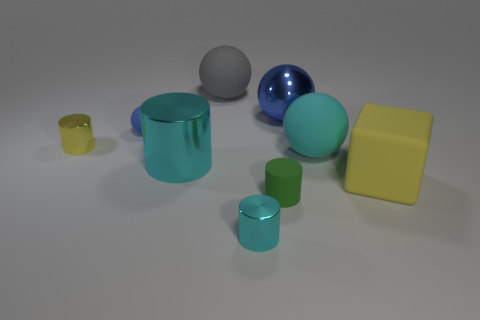Are the big gray thing and the tiny cyan object made of the same material?
Offer a terse response. No. Are there an equal number of tiny yellow metallic objects that are left of the large gray rubber object and blue metal spheres behind the block?
Your answer should be compact. Yes. There is a matte thing in front of the yellow object that is on the right side of the large gray thing; are there any yellow cubes to the left of it?
Ensure brevity in your answer.  No. Is the gray matte object the same size as the yellow cylinder?
Provide a short and direct response. No. The large shiny thing that is in front of the small metallic thing that is behind the small matte object that is in front of the small ball is what color?
Your answer should be very brief. Cyan. How many small spheres are the same color as the large shiny cylinder?
Your answer should be compact. 0. What number of big things are gray metallic things or matte cylinders?
Make the answer very short. 0. Are there any other cyan matte objects of the same shape as the big cyan matte thing?
Give a very brief answer. No. Is the shape of the big gray thing the same as the cyan rubber thing?
Offer a terse response. Yes. The sphere that is in front of the yellow thing behind the big yellow matte thing is what color?
Offer a very short reply. Cyan. 